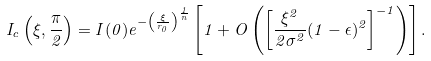Convert formula to latex. <formula><loc_0><loc_0><loc_500><loc_500>I _ { c } \left ( \xi , \frac { \pi } { 2 } \right ) = I ( 0 ) e ^ { - \left ( \frac { \xi } { r _ { 0 } } \right ) ^ { \frac { 1 } { n } } } \left [ 1 + O \left ( \left [ \frac { \xi ^ { 2 } } { 2 \sigma ^ { 2 } } ( 1 - \epsilon ) ^ { 2 } \right ] ^ { - 1 } \right ) \right ] .</formula> 